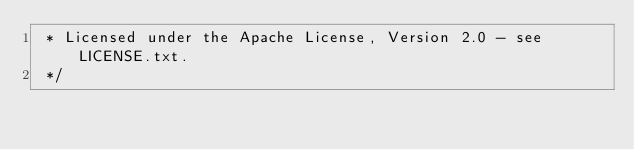Convert code to text. <code><loc_0><loc_0><loc_500><loc_500><_CSS_> * Licensed under the Apache License, Version 2.0 - see LICENSE.txt.
 */</code> 